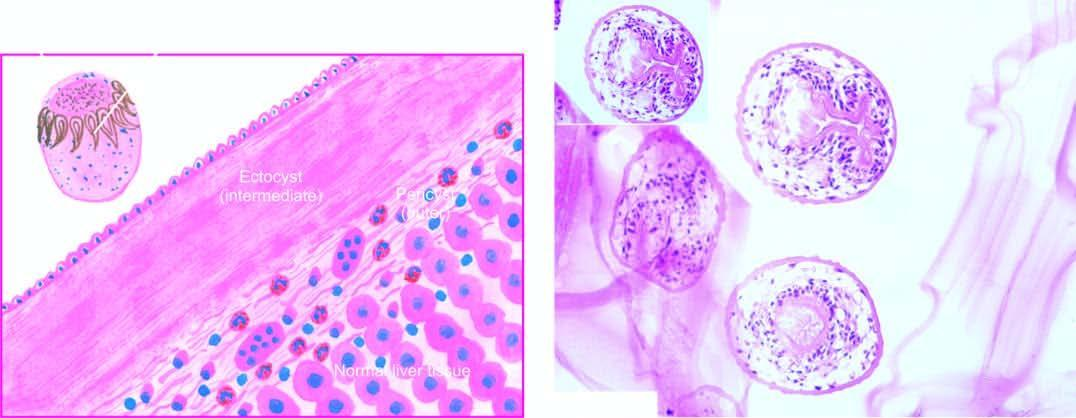does icroscopy show three layers in the wall of hydatid cyst?
Answer the question using a single word or phrase. Yes 